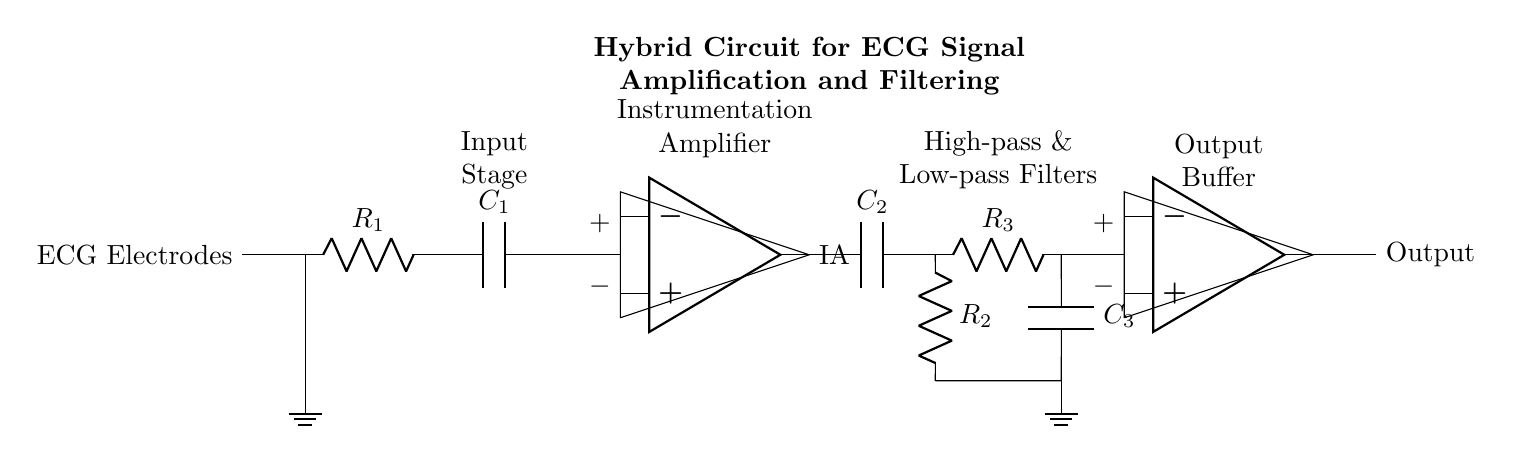What component is used for signal amplification? The component responsible for signal amplification in this circuit is the instrumentation amplifier, indicated with the label "IA" in the diagram.
Answer: instrumentation amplifier What is the total number of capacitors in the circuit? There are a total of three capacitors in the circuit, labeled as C1, C2, and C3, as seen in the input stage, high-pass filter, and low-pass filter sections.
Answer: three What is the purpose of the high-pass filter? The high-pass filter, consisting of capacitor C2 and resistor R2, is used to eliminate low-frequency noise from the ECG signal by allowing only frequencies above a certain cutoff frequency to pass.
Answer: eliminate low-frequency noise How many operational amplifiers are present in the circuit? There are two operational amplifiers in this circuit, one in the instrumentation amplifier section and another in the output buffer section.
Answer: two What is the function of the output buffer? The output buffer, which includes an operational amplifier, is used to isolate the load from the previous filtering stages, improving signal integrity and driving capability without loading the filters.
Answer: isolate the load Which resistors are present in the circuit? The circuit includes three resistors, labeled R1, R2, and R3, which form part of the input stage and the filtering components to set gain and cutoff frequencies.
Answer: R1, R2, R3 What stage follows the instrumentation amplifier? The stage that follows the instrumentation amplifier is the combination of high-pass and low-pass filters, which refine the amplified signal by removing unwanted frequency components.
Answer: high-pass and low-pass filters 